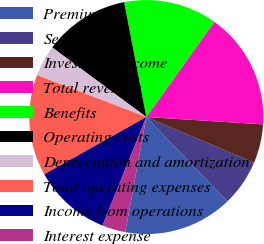<chart> <loc_0><loc_0><loc_500><loc_500><pie_chart><fcel>Premiums<fcel>Services<fcel>Investment income<fcel>Total revenues<fcel>Benefits<fcel>Operating costs<fcel>Depreciation and amortization<fcel>Total operating expenses<fcel>Income from operations<fcel>Interest expense<nl><fcel>15.05%<fcel>6.45%<fcel>5.38%<fcel>16.13%<fcel>12.9%<fcel>11.83%<fcel>4.3%<fcel>13.98%<fcel>10.75%<fcel>3.23%<nl></chart> 